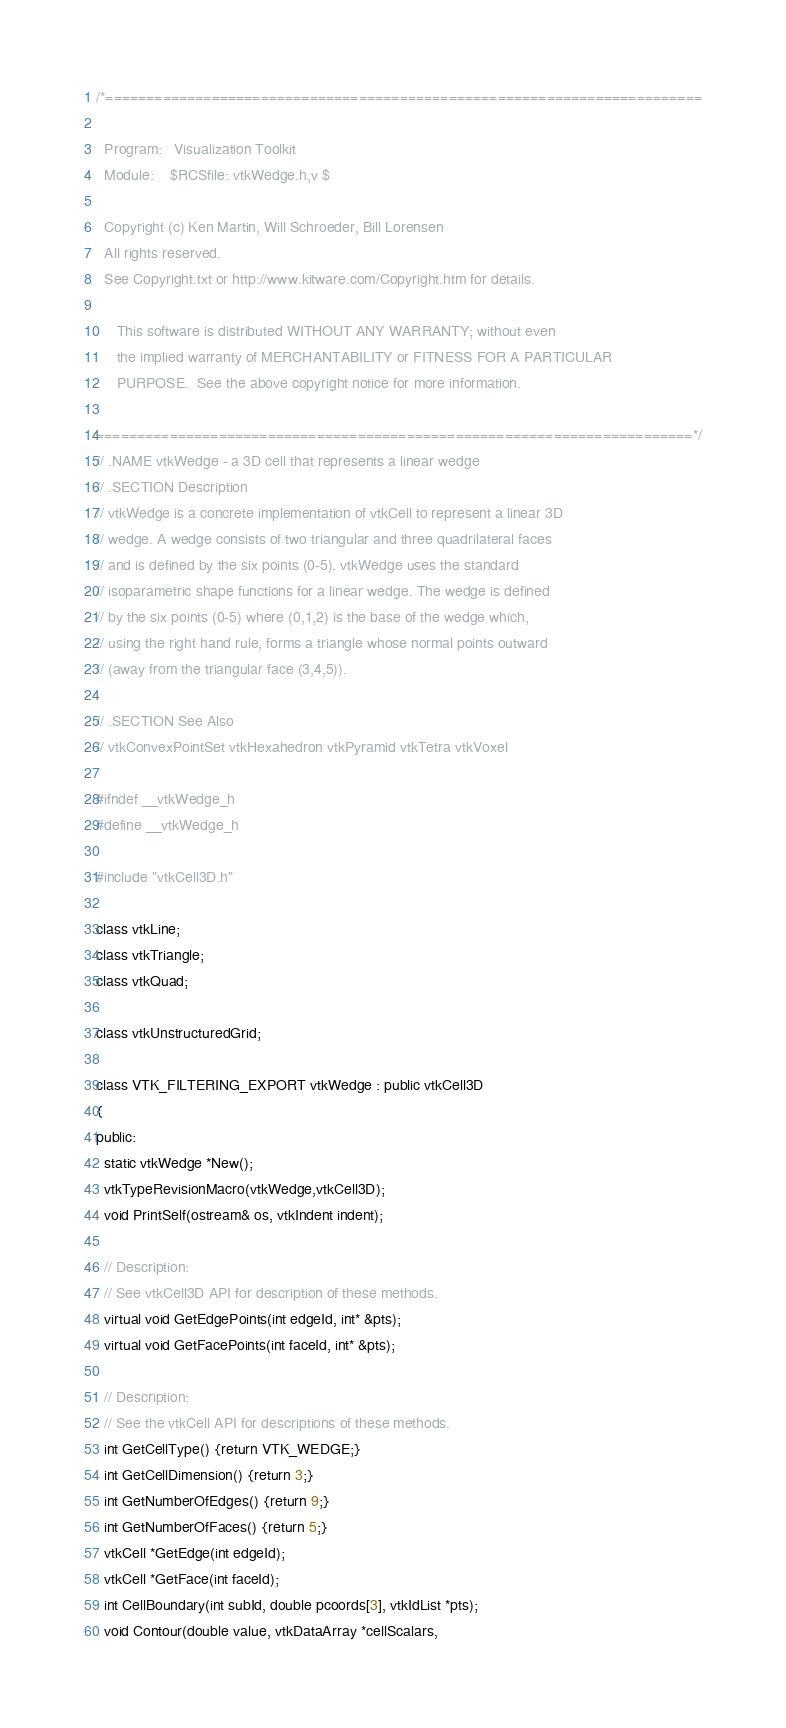<code> <loc_0><loc_0><loc_500><loc_500><_C_>/*=========================================================================

  Program:   Visualization Toolkit
  Module:    $RCSfile: vtkWedge.h,v $

  Copyright (c) Ken Martin, Will Schroeder, Bill Lorensen
  All rights reserved.
  See Copyright.txt or http://www.kitware.com/Copyright.htm for details.

     This software is distributed WITHOUT ANY WARRANTY; without even
     the implied warranty of MERCHANTABILITY or FITNESS FOR A PARTICULAR
     PURPOSE.  See the above copyright notice for more information.

=========================================================================*/
// .NAME vtkWedge - a 3D cell that represents a linear wedge
// .SECTION Description
// vtkWedge is a concrete implementation of vtkCell to represent a linear 3D
// wedge. A wedge consists of two triangular and three quadrilateral faces
// and is defined by the six points (0-5). vtkWedge uses the standard
// isoparametric shape functions for a linear wedge. The wedge is defined
// by the six points (0-5) where (0,1,2) is the base of the wedge which,
// using the right hand rule, forms a triangle whose normal points outward
// (away from the triangular face (3,4,5)).

// .SECTION See Also
// vtkConvexPointSet vtkHexahedron vtkPyramid vtkTetra vtkVoxel

#ifndef __vtkWedge_h
#define __vtkWedge_h

#include "vtkCell3D.h"

class vtkLine;
class vtkTriangle;
class vtkQuad;

class vtkUnstructuredGrid;

class VTK_FILTERING_EXPORT vtkWedge : public vtkCell3D
{
public:
  static vtkWedge *New();
  vtkTypeRevisionMacro(vtkWedge,vtkCell3D);
  void PrintSelf(ostream& os, vtkIndent indent);

  // Description:
  // See vtkCell3D API for description of these methods.
  virtual void GetEdgePoints(int edgeId, int* &pts);
  virtual void GetFacePoints(int faceId, int* &pts);

  // Description:
  // See the vtkCell API for descriptions of these methods.
  int GetCellType() {return VTK_WEDGE;}
  int GetCellDimension() {return 3;}
  int GetNumberOfEdges() {return 9;}
  int GetNumberOfFaces() {return 5;}
  vtkCell *GetEdge(int edgeId);
  vtkCell *GetFace(int faceId);
  int CellBoundary(int subId, double pcoords[3], vtkIdList *pts);
  void Contour(double value, vtkDataArray *cellScalars, </code> 